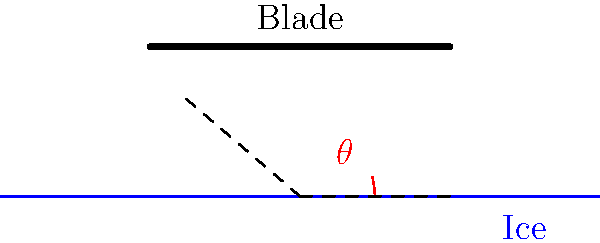In figure skating, the angle between a skater's blade edge and the ice surface is crucial for executing various techniques. Consider the cross-sectional view shown above, where $\theta$ represents this angle. If a skater's blade is positioned at a 15° angle to the ice, what is the tangent of this angle? To find the tangent of the angle, we'll follow these steps:

1. Recall the definition of tangent: $\tan \theta = \frac{\text{opposite}}{\text{adjacent}}$

2. In this case, we're given the angle $\theta = 15°$

3. We don't need to measure the sides, as we can calculate the tangent directly using the angle:

   $\tan 15° = \frac{\sin 15°}{\cos 15°}$

4. Using a calculator or trigonometric tables:
   
   $\sin 15° \approx 0.2588$
   $\cos 15° \approx 0.9659$

5. Dividing these values:

   $\tan 15° = \frac{0.2588}{0.9659} \approx 0.2679$

6. Rounding to three decimal places:

   $\tan 15° \approx 0.268$

This value represents the ratio of the blade's height above the ice to its horizontal displacement, which is crucial for understanding edge control and pressure distribution in figure skating techniques.
Answer: 0.268 